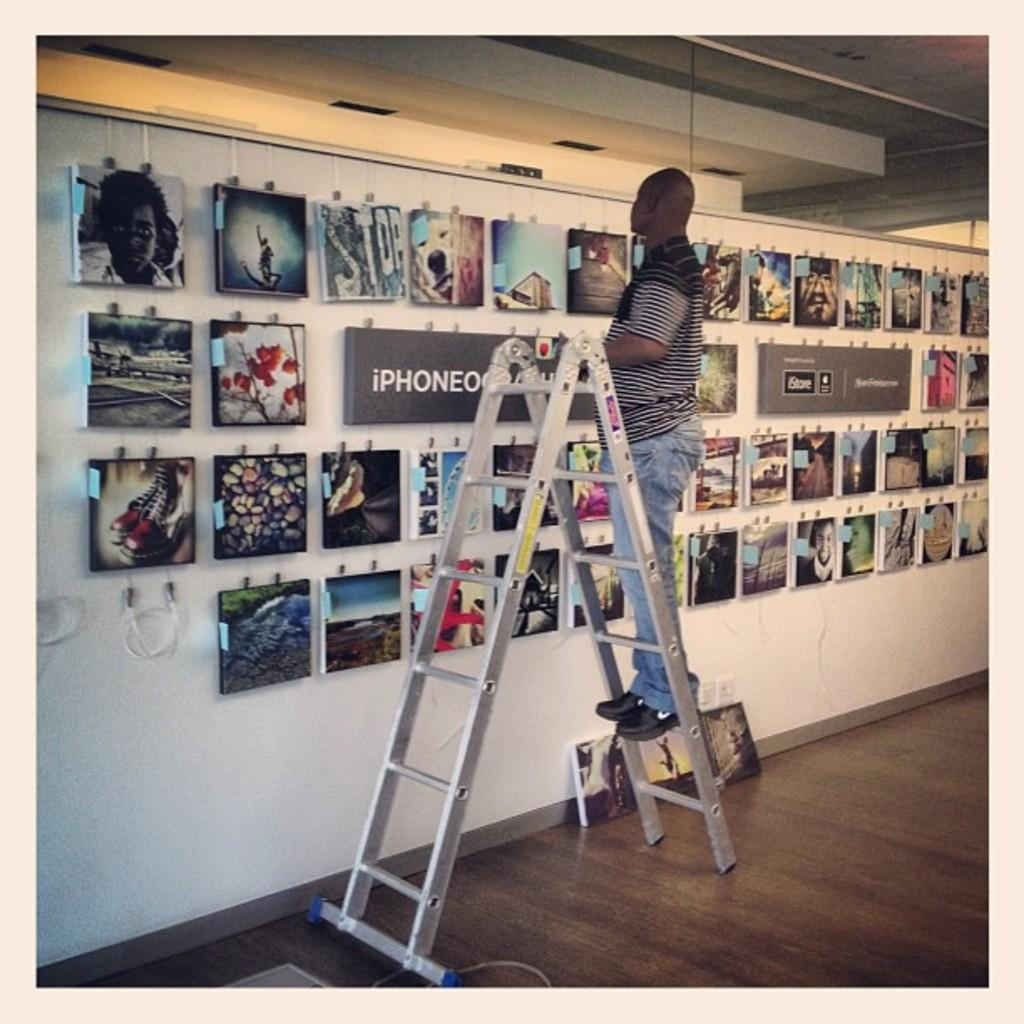<image>
Create a compact narrative representing the image presented. Man on a ladder in front of wall of pictures with the word IPhone. 